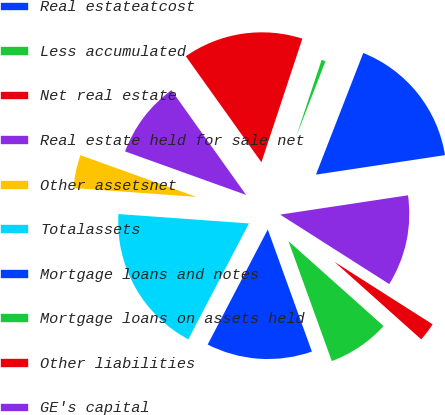Convert chart to OTSL. <chart><loc_0><loc_0><loc_500><loc_500><pie_chart><fcel>Real estateatcost<fcel>Less accumulated<fcel>Net real estate<fcel>Real estate held for sale net<fcel>Other assetsnet<fcel>Totalassets<fcel>Mortgage loans and notes<fcel>Mortgage loans on assets held<fcel>Other liabilities<fcel>GE's capital<nl><fcel>16.71%<fcel>0.81%<fcel>14.95%<fcel>9.65%<fcel>4.35%<fcel>18.48%<fcel>13.18%<fcel>7.88%<fcel>2.58%<fcel>11.41%<nl></chart> 